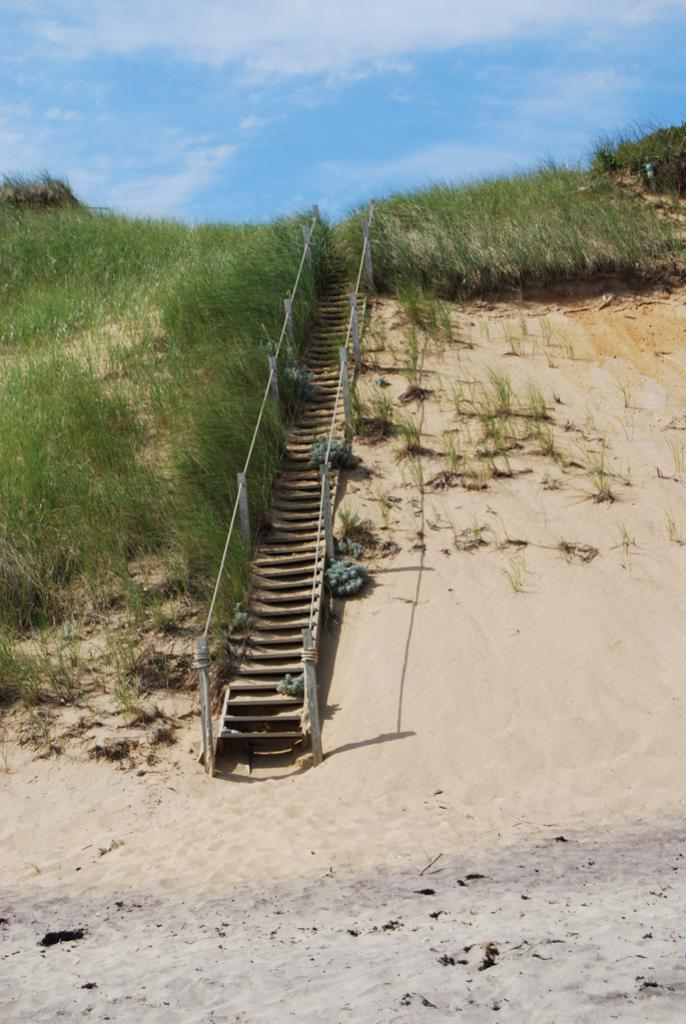What type of structure is visible in the image? There are stairs in the image. What material are the rods in the image made of? The rods in the image are made of iron. What type of vegetation is present in the image? There are plants and grass in the image. What type of terrain is visible in the background of the image? The background of the image includes sand. What is visible in the sky in the image? The sky is visible in the background of the image. How many boys are playing with the squirrel in the image? There are no boys or squirrels present in the image. What type of fiction is being read by the characters in the image? There are no characters or fiction present in the image. 